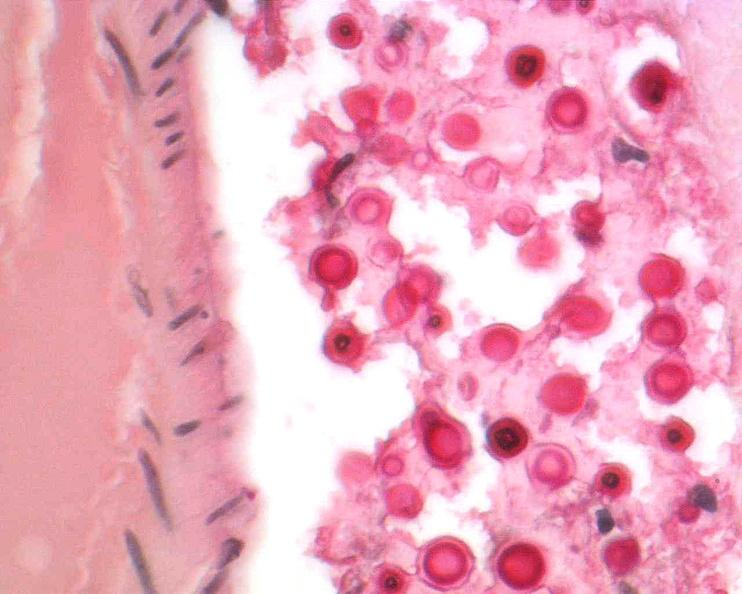does malignant lymphoma show brain, cryptococcal meningitis?
Answer the question using a single word or phrase. No 